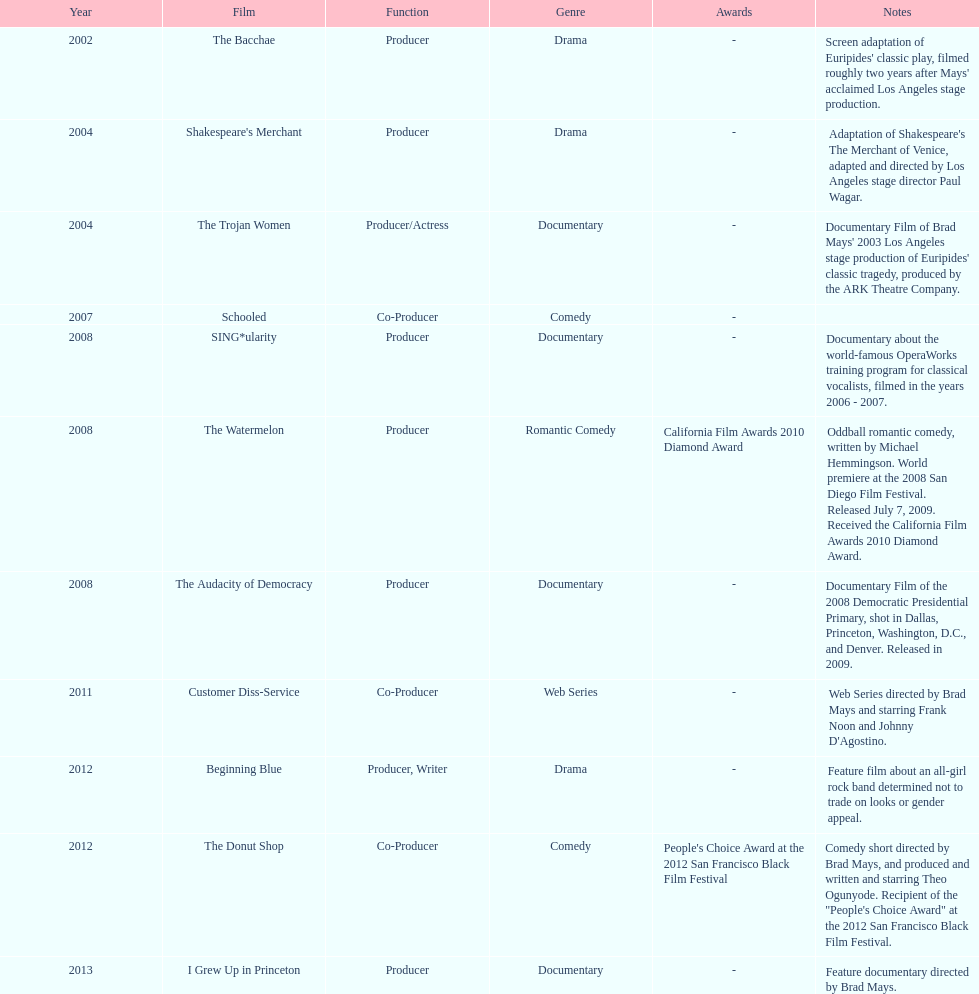Which film was before the audacity of democracy? The Watermelon. 